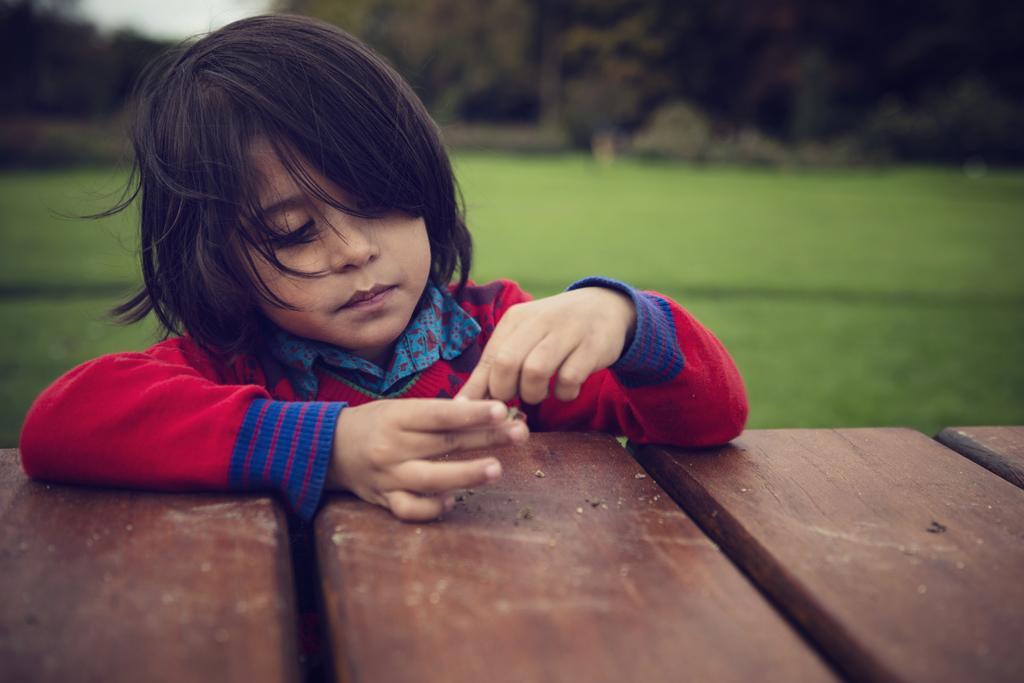In one or two sentences, can you explain what this image depicts? As we can see in the image there is a bench, a boy wearing white color jacket, grass, trees and the background is blurred. 